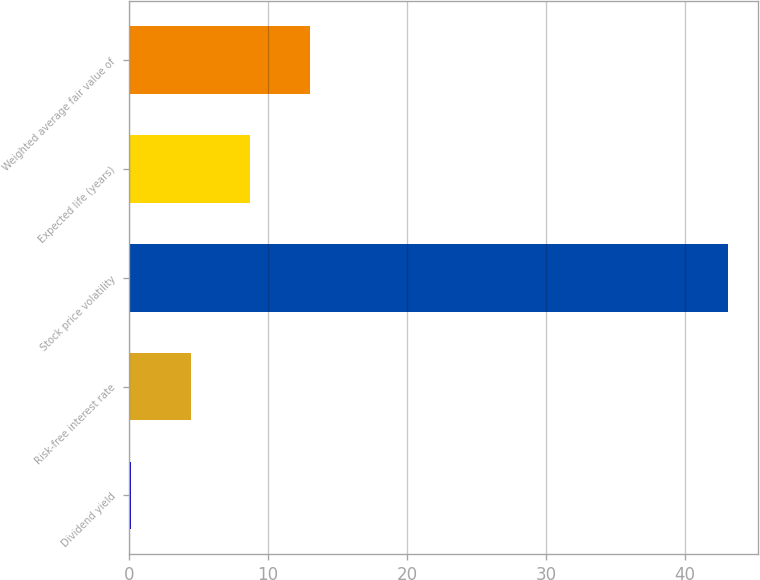<chart> <loc_0><loc_0><loc_500><loc_500><bar_chart><fcel>Dividend yield<fcel>Risk-free interest rate<fcel>Stock price volatility<fcel>Expected life (years)<fcel>Weighted average fair value of<nl><fcel>0.13<fcel>4.43<fcel>43.1<fcel>8.73<fcel>13.03<nl></chart> 